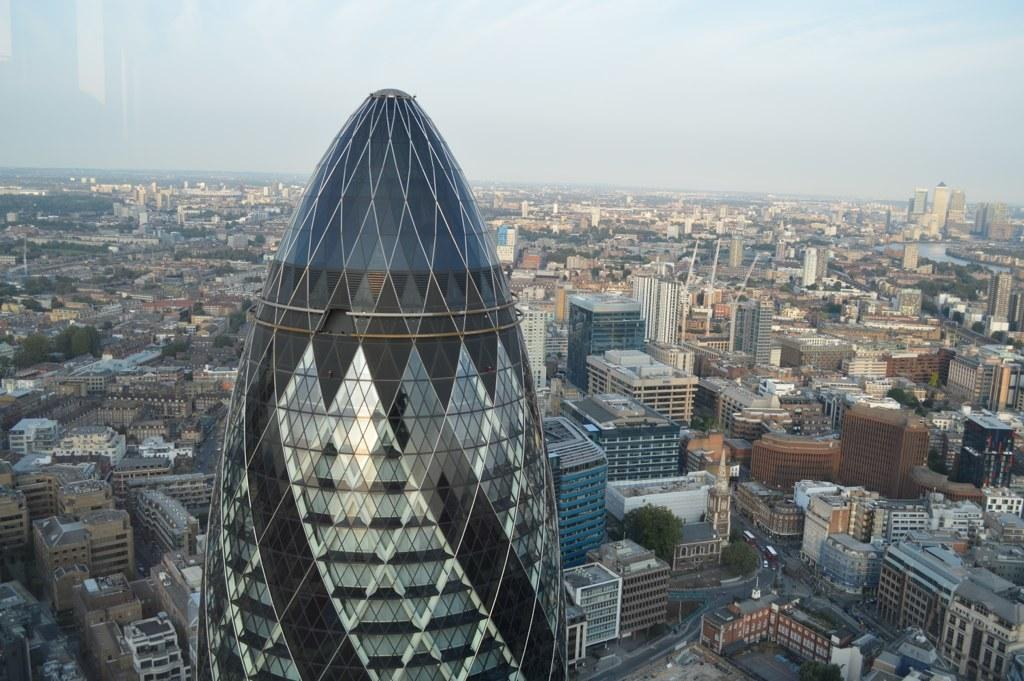What type of structures can be seen in the image? There are buildings in the image. How are the buildings arranged in the image? The buildings are arranged from left to right. What else can be seen in the image besides buildings? There are trees visible in the image. What is present on the road in the image? There are vehicles on the road in the image. What type of company is responsible for the care of the trees in the image? There is no information about a company or the care of the trees in the image. 